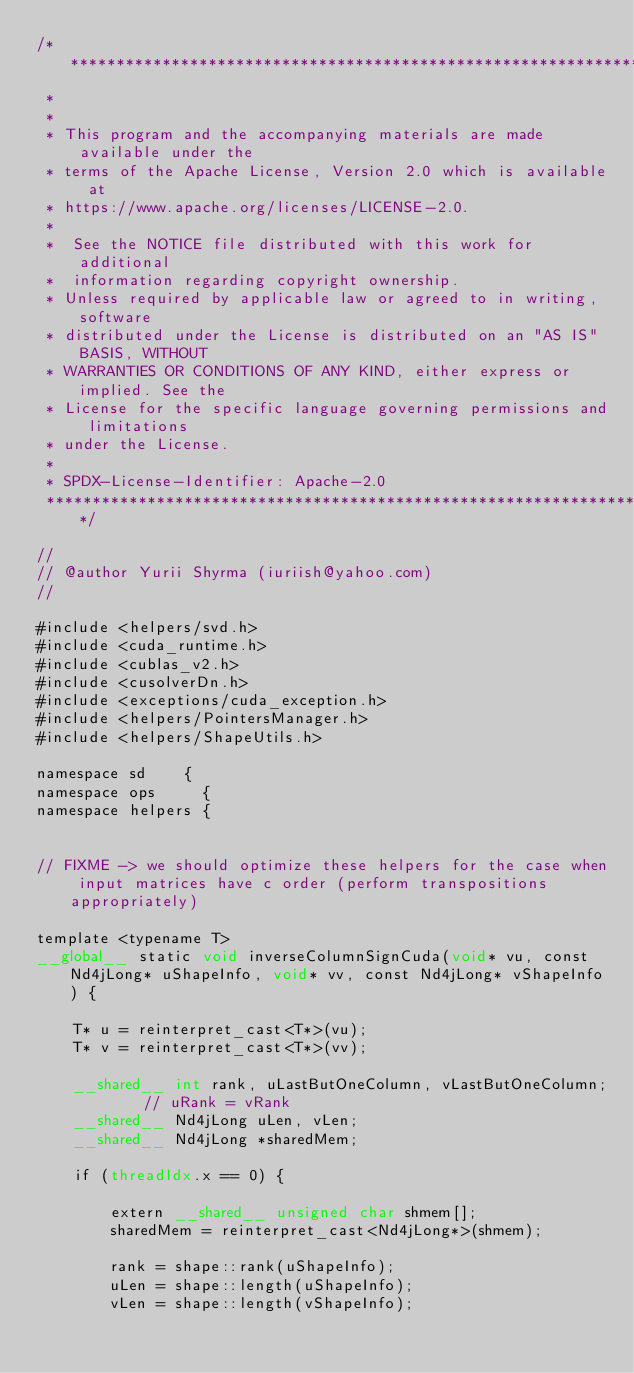<code> <loc_0><loc_0><loc_500><loc_500><_Cuda_>/* ******************************************************************************
 *
 *
 * This program and the accompanying materials are made available under the
 * terms of the Apache License, Version 2.0 which is available at
 * https://www.apache.org/licenses/LICENSE-2.0.
 *
 *  See the NOTICE file distributed with this work for additional
 *  information regarding copyright ownership.
 * Unless required by applicable law or agreed to in writing, software
 * distributed under the License is distributed on an "AS IS" BASIS, WITHOUT
 * WARRANTIES OR CONDITIONS OF ANY KIND, either express or implied. See the
 * License for the specific language governing permissions and limitations
 * under the License.
 *
 * SPDX-License-Identifier: Apache-2.0
 ******************************************************************************/

//
// @author Yurii Shyrma (iuriish@yahoo.com)
//

#include <helpers/svd.h>
#include <cuda_runtime.h>
#include <cublas_v2.h>
#include <cusolverDn.h>
#include <exceptions/cuda_exception.h>
#include <helpers/PointersManager.h>
#include <helpers/ShapeUtils.h>

namespace sd    {
namespace ops     {
namespace helpers {


// FIXME -> we should optimize these helpers for the case when input matrices have c order (perform transpositions appropriately)

template <typename T>
__global__ static void inverseColumnSignCuda(void* vu, const Nd4jLong* uShapeInfo, void* vv, const Nd4jLong* vShapeInfo) {

    T* u = reinterpret_cast<T*>(vu);
    T* v = reinterpret_cast<T*>(vv);

    __shared__ int rank, uLastButOneColumn, vLastButOneColumn;    // uRank = vRank
    __shared__ Nd4jLong uLen, vLen;
    __shared__ Nd4jLong *sharedMem;

    if (threadIdx.x == 0) {

        extern __shared__ unsigned char shmem[];
        sharedMem = reinterpret_cast<Nd4jLong*>(shmem);

        rank = shape::rank(uShapeInfo);
        uLen = shape::length(uShapeInfo);
        vLen = shape::length(vShapeInfo);
</code> 